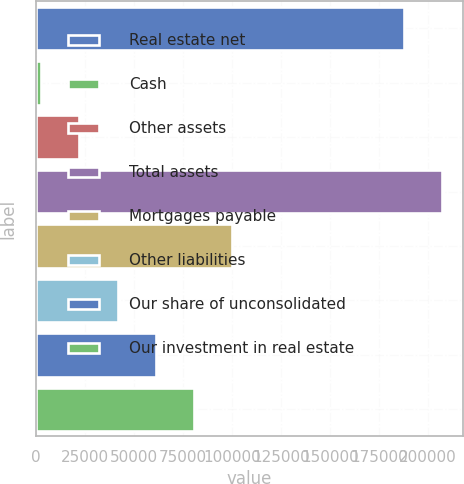Convert chart. <chart><loc_0><loc_0><loc_500><loc_500><bar_chart><fcel>Real estate net<fcel>Cash<fcel>Other assets<fcel>Total assets<fcel>Mortgages payable<fcel>Other liabilities<fcel>Our share of unconsolidated<fcel>Our investment in real estate<nl><fcel>187910<fcel>2604<fcel>22101.6<fcel>207408<fcel>100092<fcel>41599.2<fcel>61096.8<fcel>80594.4<nl></chart> 